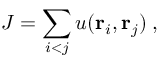<formula> <loc_0><loc_0><loc_500><loc_500>J = \sum _ { i < j } u ( { r } _ { i } , { r } _ { j } ) \, ,</formula> 